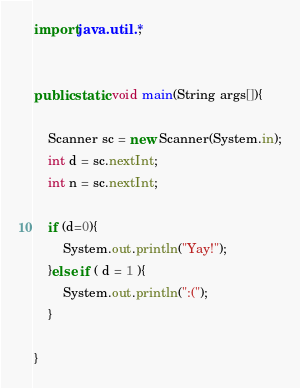<code> <loc_0><loc_0><loc_500><loc_500><_Java_>import java.util.*;


public static void main(String args[]){

	Scanner sc = new Scanner(System.in);
	int d = sc.nextInt;
	int n = sc.nextInt;

	if (d=0){
		System.out.println("Yay!");
	}else if ( d = 1 ){
		System.out.println(":(");
	}

}
</code> 